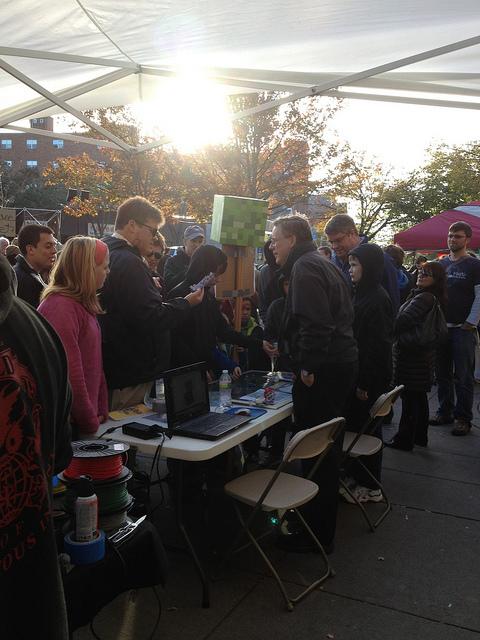Is it noon or some other time of day?
Quick response, please. Other time. Is the laptop open or closed?
Be succinct. Open. How many people are sitting down?
Concise answer only. 0. 